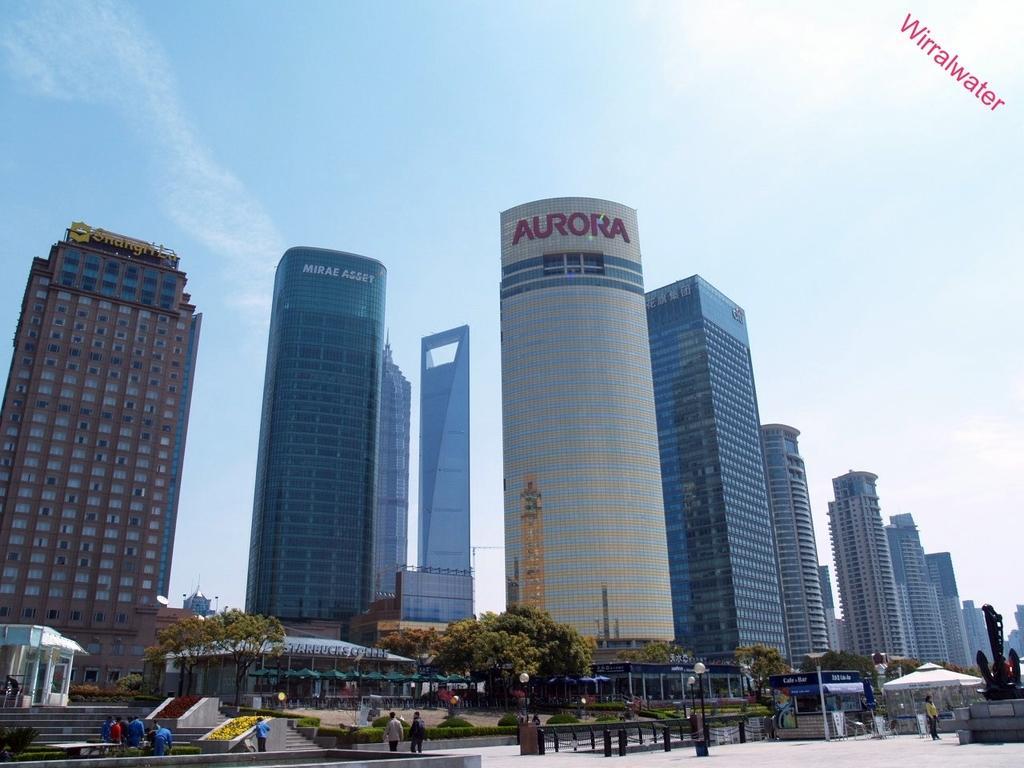Describe this image in one or two sentences. In this image I can see the group of people with different color dresses. I can see the light poles, boards, tent, sheds and many trees. In the background I can see the buildings, clouds and the sky. 